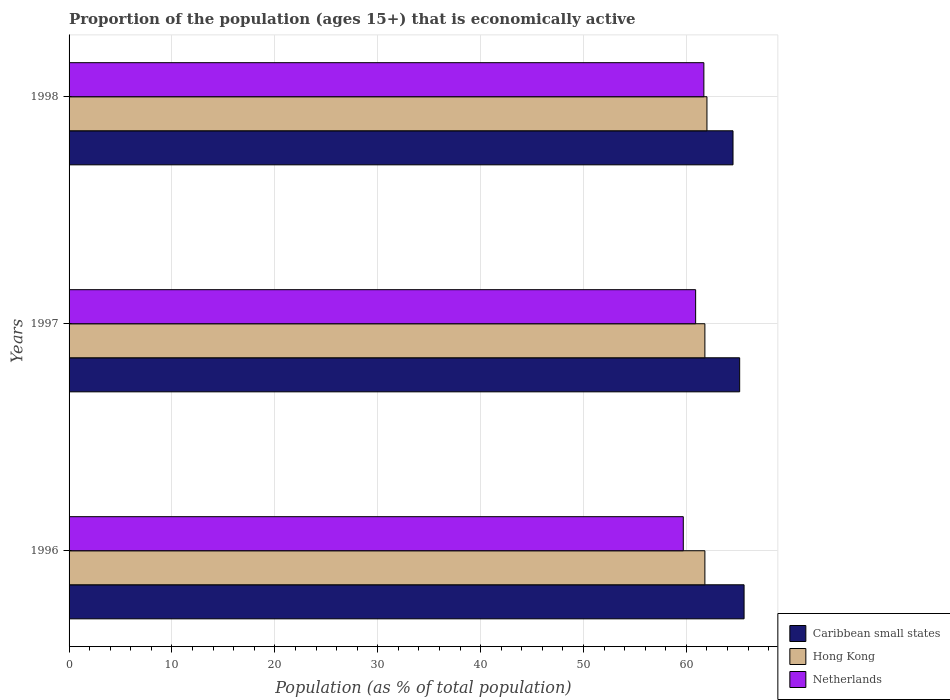How many different coloured bars are there?
Keep it short and to the point. 3. How many groups of bars are there?
Provide a succinct answer. 3. Are the number of bars per tick equal to the number of legend labels?
Give a very brief answer. Yes. Are the number of bars on each tick of the Y-axis equal?
Offer a very short reply. Yes. How many bars are there on the 2nd tick from the bottom?
Provide a succinct answer. 3. What is the label of the 3rd group of bars from the top?
Offer a very short reply. 1996. What is the proportion of the population that is economically active in Netherlands in 1996?
Keep it short and to the point. 59.7. Across all years, what is the maximum proportion of the population that is economically active in Hong Kong?
Offer a terse response. 62. Across all years, what is the minimum proportion of the population that is economically active in Hong Kong?
Provide a succinct answer. 61.8. In which year was the proportion of the population that is economically active in Hong Kong maximum?
Your answer should be compact. 1998. What is the total proportion of the population that is economically active in Netherlands in the graph?
Give a very brief answer. 182.3. What is the difference between the proportion of the population that is economically active in Netherlands in 1996 and that in 1997?
Provide a succinct answer. -1.2. What is the difference between the proportion of the population that is economically active in Hong Kong in 1996 and the proportion of the population that is economically active in Netherlands in 1998?
Give a very brief answer. 0.1. What is the average proportion of the population that is economically active in Caribbean small states per year?
Make the answer very short. 65.11. In the year 1998, what is the difference between the proportion of the population that is economically active in Netherlands and proportion of the population that is economically active in Caribbean small states?
Give a very brief answer. -2.83. What is the ratio of the proportion of the population that is economically active in Netherlands in 1997 to that in 1998?
Ensure brevity in your answer.  0.99. Is the proportion of the population that is economically active in Netherlands in 1996 less than that in 1997?
Give a very brief answer. Yes. What is the difference between the highest and the second highest proportion of the population that is economically active in Netherlands?
Your answer should be compact. 0.8. What is the difference between the highest and the lowest proportion of the population that is economically active in Hong Kong?
Your answer should be very brief. 0.2. In how many years, is the proportion of the population that is economically active in Netherlands greater than the average proportion of the population that is economically active in Netherlands taken over all years?
Keep it short and to the point. 2. What does the 2nd bar from the bottom in 1996 represents?
Your answer should be compact. Hong Kong. Is it the case that in every year, the sum of the proportion of the population that is economically active in Hong Kong and proportion of the population that is economically active in Netherlands is greater than the proportion of the population that is economically active in Caribbean small states?
Ensure brevity in your answer.  Yes. How many bars are there?
Ensure brevity in your answer.  9. Are the values on the major ticks of X-axis written in scientific E-notation?
Give a very brief answer. No. Does the graph contain any zero values?
Give a very brief answer. No. Does the graph contain grids?
Your answer should be very brief. Yes. What is the title of the graph?
Give a very brief answer. Proportion of the population (ages 15+) that is economically active. What is the label or title of the X-axis?
Offer a terse response. Population (as % of total population). What is the label or title of the Y-axis?
Your answer should be very brief. Years. What is the Population (as % of total population) in Caribbean small states in 1996?
Ensure brevity in your answer.  65.61. What is the Population (as % of total population) of Hong Kong in 1996?
Provide a short and direct response. 61.8. What is the Population (as % of total population) in Netherlands in 1996?
Your answer should be very brief. 59.7. What is the Population (as % of total population) in Caribbean small states in 1997?
Keep it short and to the point. 65.18. What is the Population (as % of total population) in Hong Kong in 1997?
Offer a terse response. 61.8. What is the Population (as % of total population) of Netherlands in 1997?
Your answer should be very brief. 60.9. What is the Population (as % of total population) of Caribbean small states in 1998?
Ensure brevity in your answer.  64.53. What is the Population (as % of total population) in Netherlands in 1998?
Provide a short and direct response. 61.7. Across all years, what is the maximum Population (as % of total population) of Caribbean small states?
Give a very brief answer. 65.61. Across all years, what is the maximum Population (as % of total population) in Netherlands?
Keep it short and to the point. 61.7. Across all years, what is the minimum Population (as % of total population) in Caribbean small states?
Provide a succinct answer. 64.53. Across all years, what is the minimum Population (as % of total population) of Hong Kong?
Give a very brief answer. 61.8. Across all years, what is the minimum Population (as % of total population) in Netherlands?
Give a very brief answer. 59.7. What is the total Population (as % of total population) in Caribbean small states in the graph?
Give a very brief answer. 195.32. What is the total Population (as % of total population) of Hong Kong in the graph?
Offer a very short reply. 185.6. What is the total Population (as % of total population) of Netherlands in the graph?
Provide a succinct answer. 182.3. What is the difference between the Population (as % of total population) in Caribbean small states in 1996 and that in 1997?
Your response must be concise. 0.43. What is the difference between the Population (as % of total population) in Hong Kong in 1996 and that in 1997?
Make the answer very short. 0. What is the difference between the Population (as % of total population) of Caribbean small states in 1996 and that in 1998?
Your answer should be compact. 1.08. What is the difference between the Population (as % of total population) in Hong Kong in 1996 and that in 1998?
Your response must be concise. -0.2. What is the difference between the Population (as % of total population) of Netherlands in 1996 and that in 1998?
Offer a very short reply. -2. What is the difference between the Population (as % of total population) of Caribbean small states in 1997 and that in 1998?
Give a very brief answer. 0.65. What is the difference between the Population (as % of total population) in Caribbean small states in 1996 and the Population (as % of total population) in Hong Kong in 1997?
Provide a succinct answer. 3.81. What is the difference between the Population (as % of total population) of Caribbean small states in 1996 and the Population (as % of total population) of Netherlands in 1997?
Provide a succinct answer. 4.71. What is the difference between the Population (as % of total population) of Caribbean small states in 1996 and the Population (as % of total population) of Hong Kong in 1998?
Make the answer very short. 3.61. What is the difference between the Population (as % of total population) in Caribbean small states in 1996 and the Population (as % of total population) in Netherlands in 1998?
Your response must be concise. 3.91. What is the difference between the Population (as % of total population) in Caribbean small states in 1997 and the Population (as % of total population) in Hong Kong in 1998?
Ensure brevity in your answer.  3.18. What is the difference between the Population (as % of total population) of Caribbean small states in 1997 and the Population (as % of total population) of Netherlands in 1998?
Offer a terse response. 3.48. What is the difference between the Population (as % of total population) in Hong Kong in 1997 and the Population (as % of total population) in Netherlands in 1998?
Your response must be concise. 0.1. What is the average Population (as % of total population) of Caribbean small states per year?
Provide a short and direct response. 65.11. What is the average Population (as % of total population) in Hong Kong per year?
Your answer should be compact. 61.87. What is the average Population (as % of total population) in Netherlands per year?
Provide a succinct answer. 60.77. In the year 1996, what is the difference between the Population (as % of total population) of Caribbean small states and Population (as % of total population) of Hong Kong?
Provide a short and direct response. 3.81. In the year 1996, what is the difference between the Population (as % of total population) of Caribbean small states and Population (as % of total population) of Netherlands?
Keep it short and to the point. 5.91. In the year 1997, what is the difference between the Population (as % of total population) of Caribbean small states and Population (as % of total population) of Hong Kong?
Your answer should be very brief. 3.38. In the year 1997, what is the difference between the Population (as % of total population) of Caribbean small states and Population (as % of total population) of Netherlands?
Provide a succinct answer. 4.28. In the year 1998, what is the difference between the Population (as % of total population) of Caribbean small states and Population (as % of total population) of Hong Kong?
Offer a terse response. 2.53. In the year 1998, what is the difference between the Population (as % of total population) of Caribbean small states and Population (as % of total population) of Netherlands?
Provide a succinct answer. 2.83. In the year 1998, what is the difference between the Population (as % of total population) in Hong Kong and Population (as % of total population) in Netherlands?
Give a very brief answer. 0.3. What is the ratio of the Population (as % of total population) of Caribbean small states in 1996 to that in 1997?
Provide a short and direct response. 1.01. What is the ratio of the Population (as % of total population) of Hong Kong in 1996 to that in 1997?
Keep it short and to the point. 1. What is the ratio of the Population (as % of total population) in Netherlands in 1996 to that in 1997?
Your answer should be very brief. 0.98. What is the ratio of the Population (as % of total population) in Caribbean small states in 1996 to that in 1998?
Provide a succinct answer. 1.02. What is the ratio of the Population (as % of total population) of Hong Kong in 1996 to that in 1998?
Provide a succinct answer. 1. What is the ratio of the Population (as % of total population) of Netherlands in 1996 to that in 1998?
Your answer should be compact. 0.97. What is the ratio of the Population (as % of total population) in Hong Kong in 1997 to that in 1998?
Your answer should be compact. 1. What is the ratio of the Population (as % of total population) in Netherlands in 1997 to that in 1998?
Keep it short and to the point. 0.99. What is the difference between the highest and the second highest Population (as % of total population) in Caribbean small states?
Ensure brevity in your answer.  0.43. What is the difference between the highest and the second highest Population (as % of total population) in Hong Kong?
Keep it short and to the point. 0.2. What is the difference between the highest and the lowest Population (as % of total population) of Caribbean small states?
Your response must be concise. 1.08. What is the difference between the highest and the lowest Population (as % of total population) in Netherlands?
Ensure brevity in your answer.  2. 